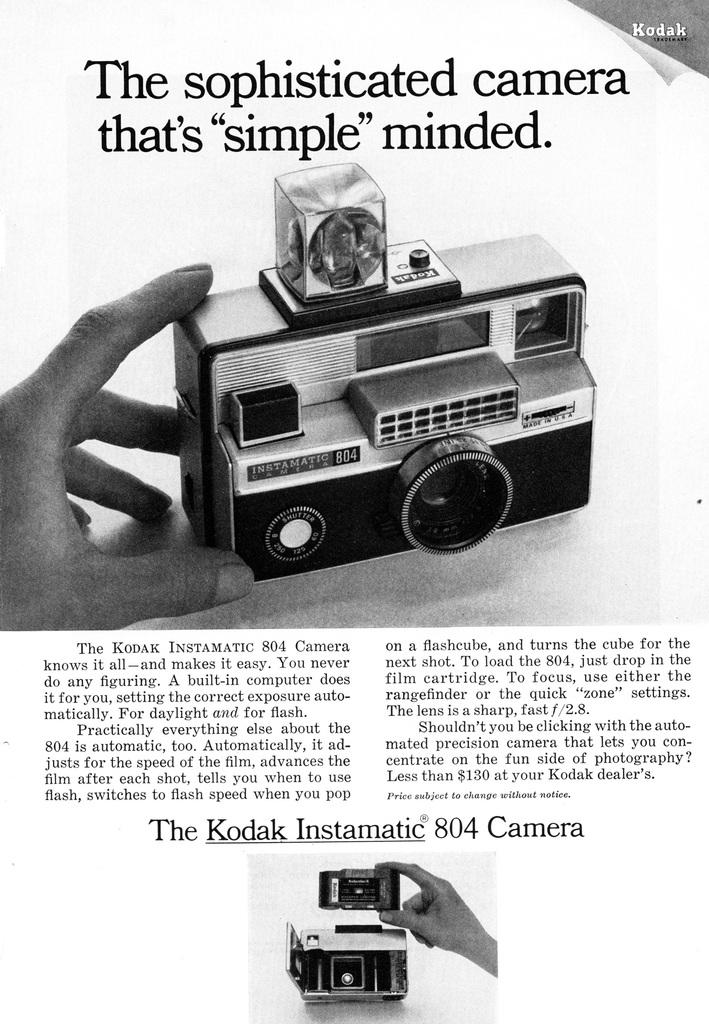What is the color scheme of the image? The image is black and white. What is the person in the image doing? The person is holding a camera in the image. Where can text be found in the image? There is text at the bottom and top of the image. What type of grain is being harvested in the image? There is no grain or harvesting activity present in the image. Can you tell me how many lettuce leaves are visible in the image? There are no lettuce leaves present in the image. 